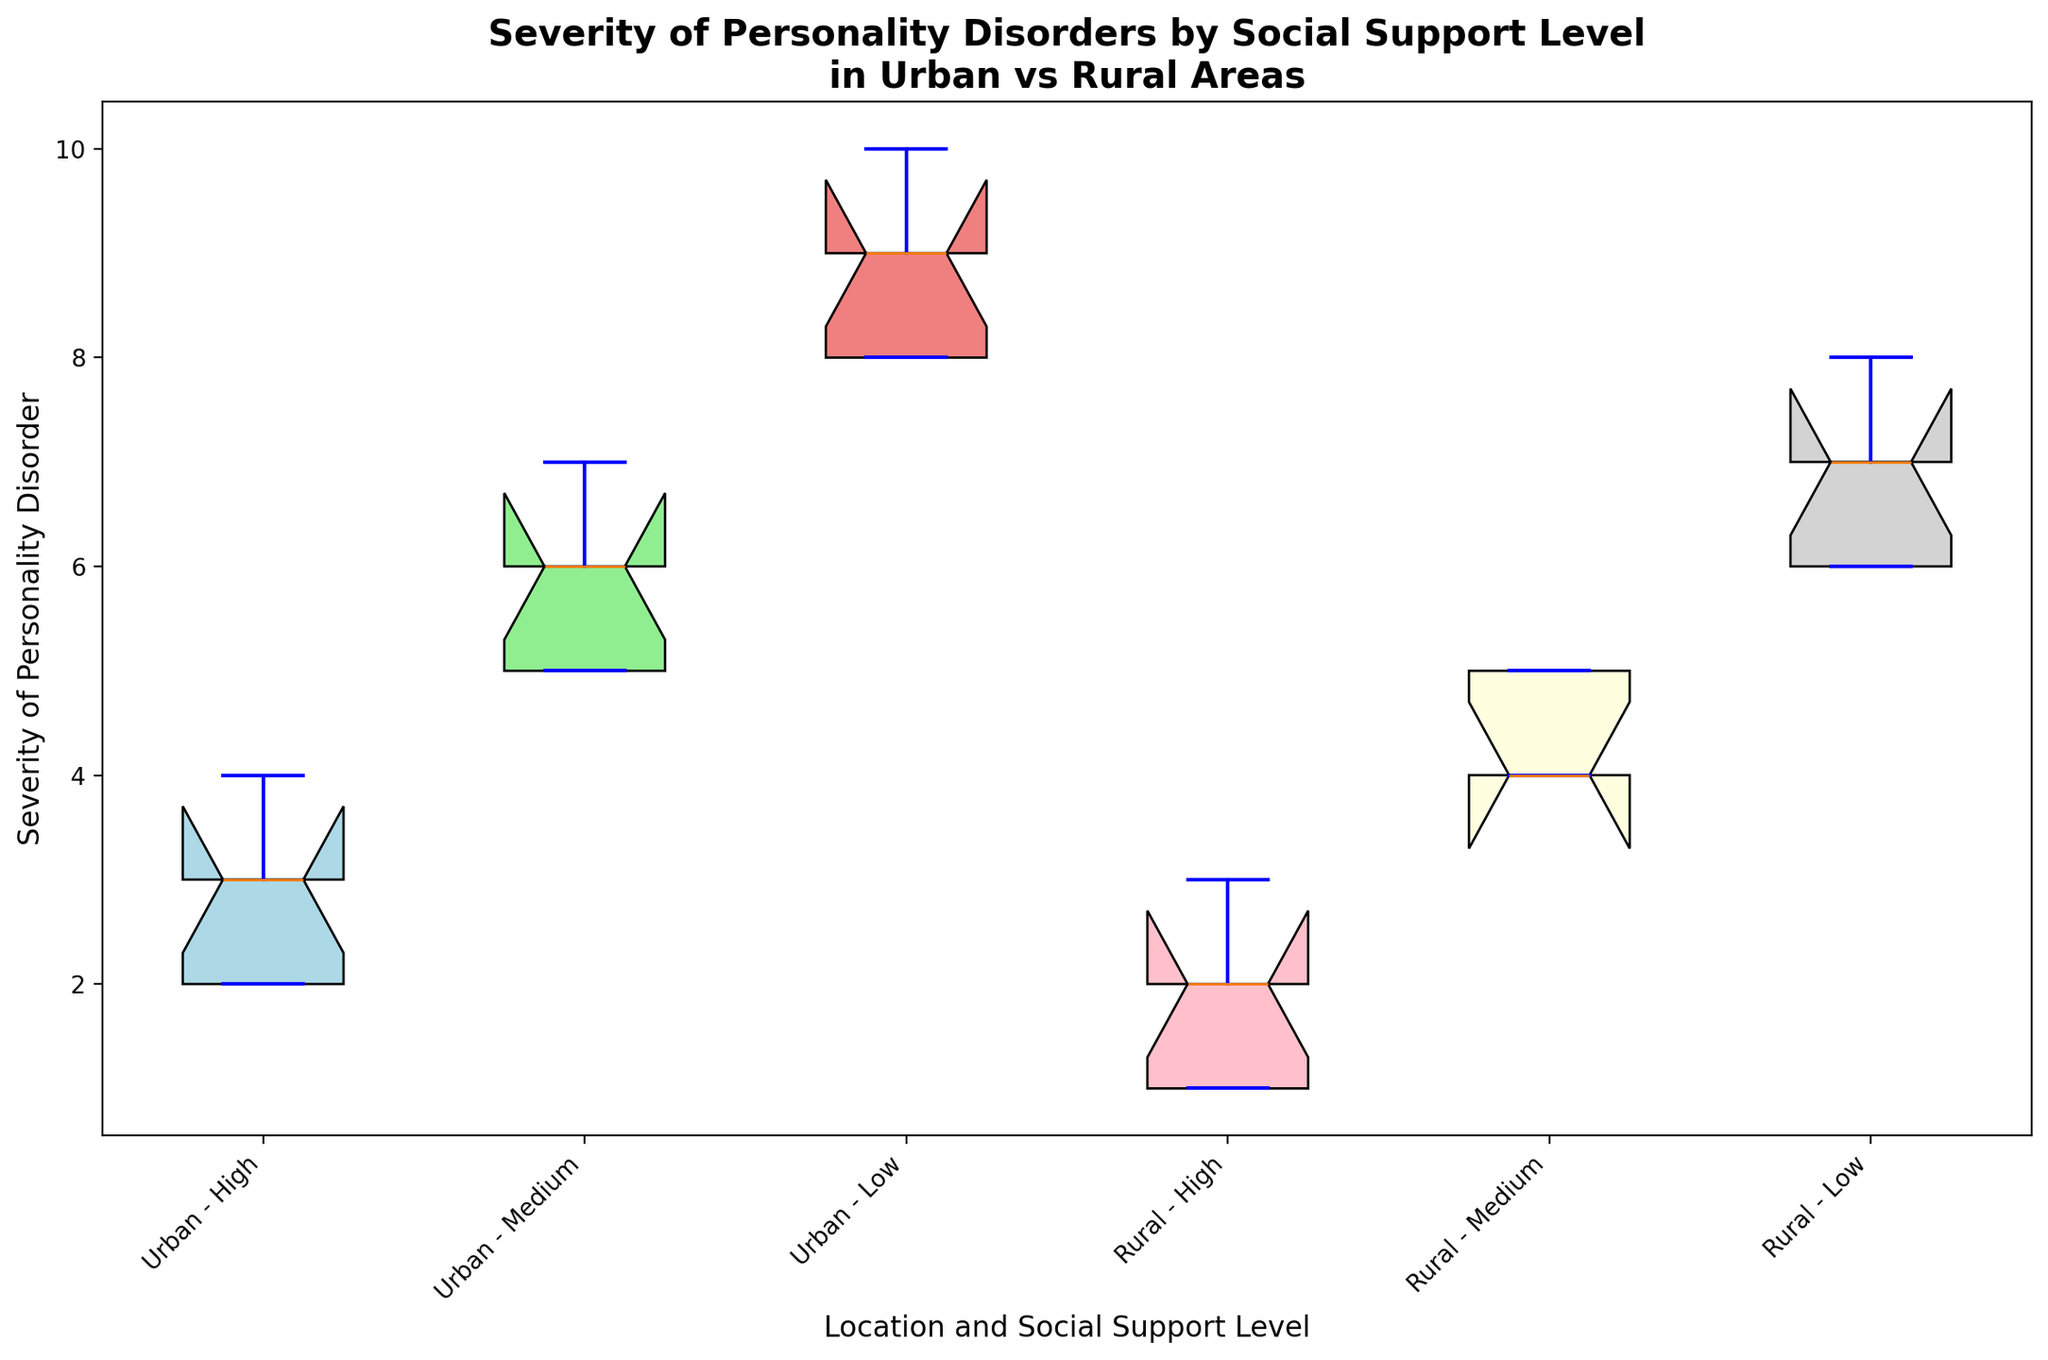Which social support level in urban areas has the highest median severity of personality disorders? By examining the boxplot, we observe that the median line within the box that indicates the highest severity is for the "Low" social support level in urban areas.
Answer: Low Which location and social support level combination shows the lowest overall severity of personality disorders? The combination "Rural - High" shows the lowest box plot distribution indicating the lowest severity levels, and the minimum value shown is 1.
Answer: Rural - High Between urban and rural areas, which one shows a larger spread in severity for those with medium social support levels? We can compare the range between the upper and lower whiskers in the boxes. The "Urban - Medium" boxplot shows a larger spread when compared to "Rural - Medium".
Answer: Urban What is the difference in median severity between urban high social support and rural high social support levels? The medians can be observed as the horizontal lines inside the boxes. The median for "Urban - High" appears to be 3, while for "Rural - High", it appears to be 2. The difference is 3 - 2 = 1.
Answer: 1 Which group has a more varied severity of personality disorders for low social support levels, urban or rural areas? We look at the length of the boxes; the box for "Urban - Low" is longer than for "Rural - Low", indicating more variability in urban areas.
Answer: Urban Is there any overlap in the severity of personality disorders between urban and rural areas for high social support levels? Overlap can be seen if the ranges of the box plots intersect. For "High" social support levels, the ranges from the whiskers do not overlap between urban (2-4) and rural (1-3) areas.
Answer: No Which group among urban and rural with low social support exhibits the highest extreme value (outlier) for severity? The data points beyond the whiskers are considered outliers. The highest outlier is observed in the "Urban - Low" category which has its extreme value reaching 10.
Answer: Urban For rural areas, how does the severity distribution change as social support level decreases from high to low? Observing the boxes for rural areas in sequence (High, Medium, Low), the median and overall severity shift higher as the social support decreases.
Answer: Increases Which social support level shows the smallest interquartile range (IQR) in urban areas? The IQR is indicated by the height of the box. The smallest IQR in urban areas is seen in the "High" social support level.
Answer: High 